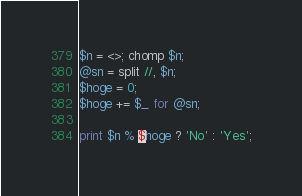Convert code to text. <code><loc_0><loc_0><loc_500><loc_500><_Perl_>$n = <>; chomp $n;
@sn = split //, $n;
$hoge = 0;
$hoge += $_ for @sn;

print $n % $hoge ? 'No' : 'Yes';
</code> 